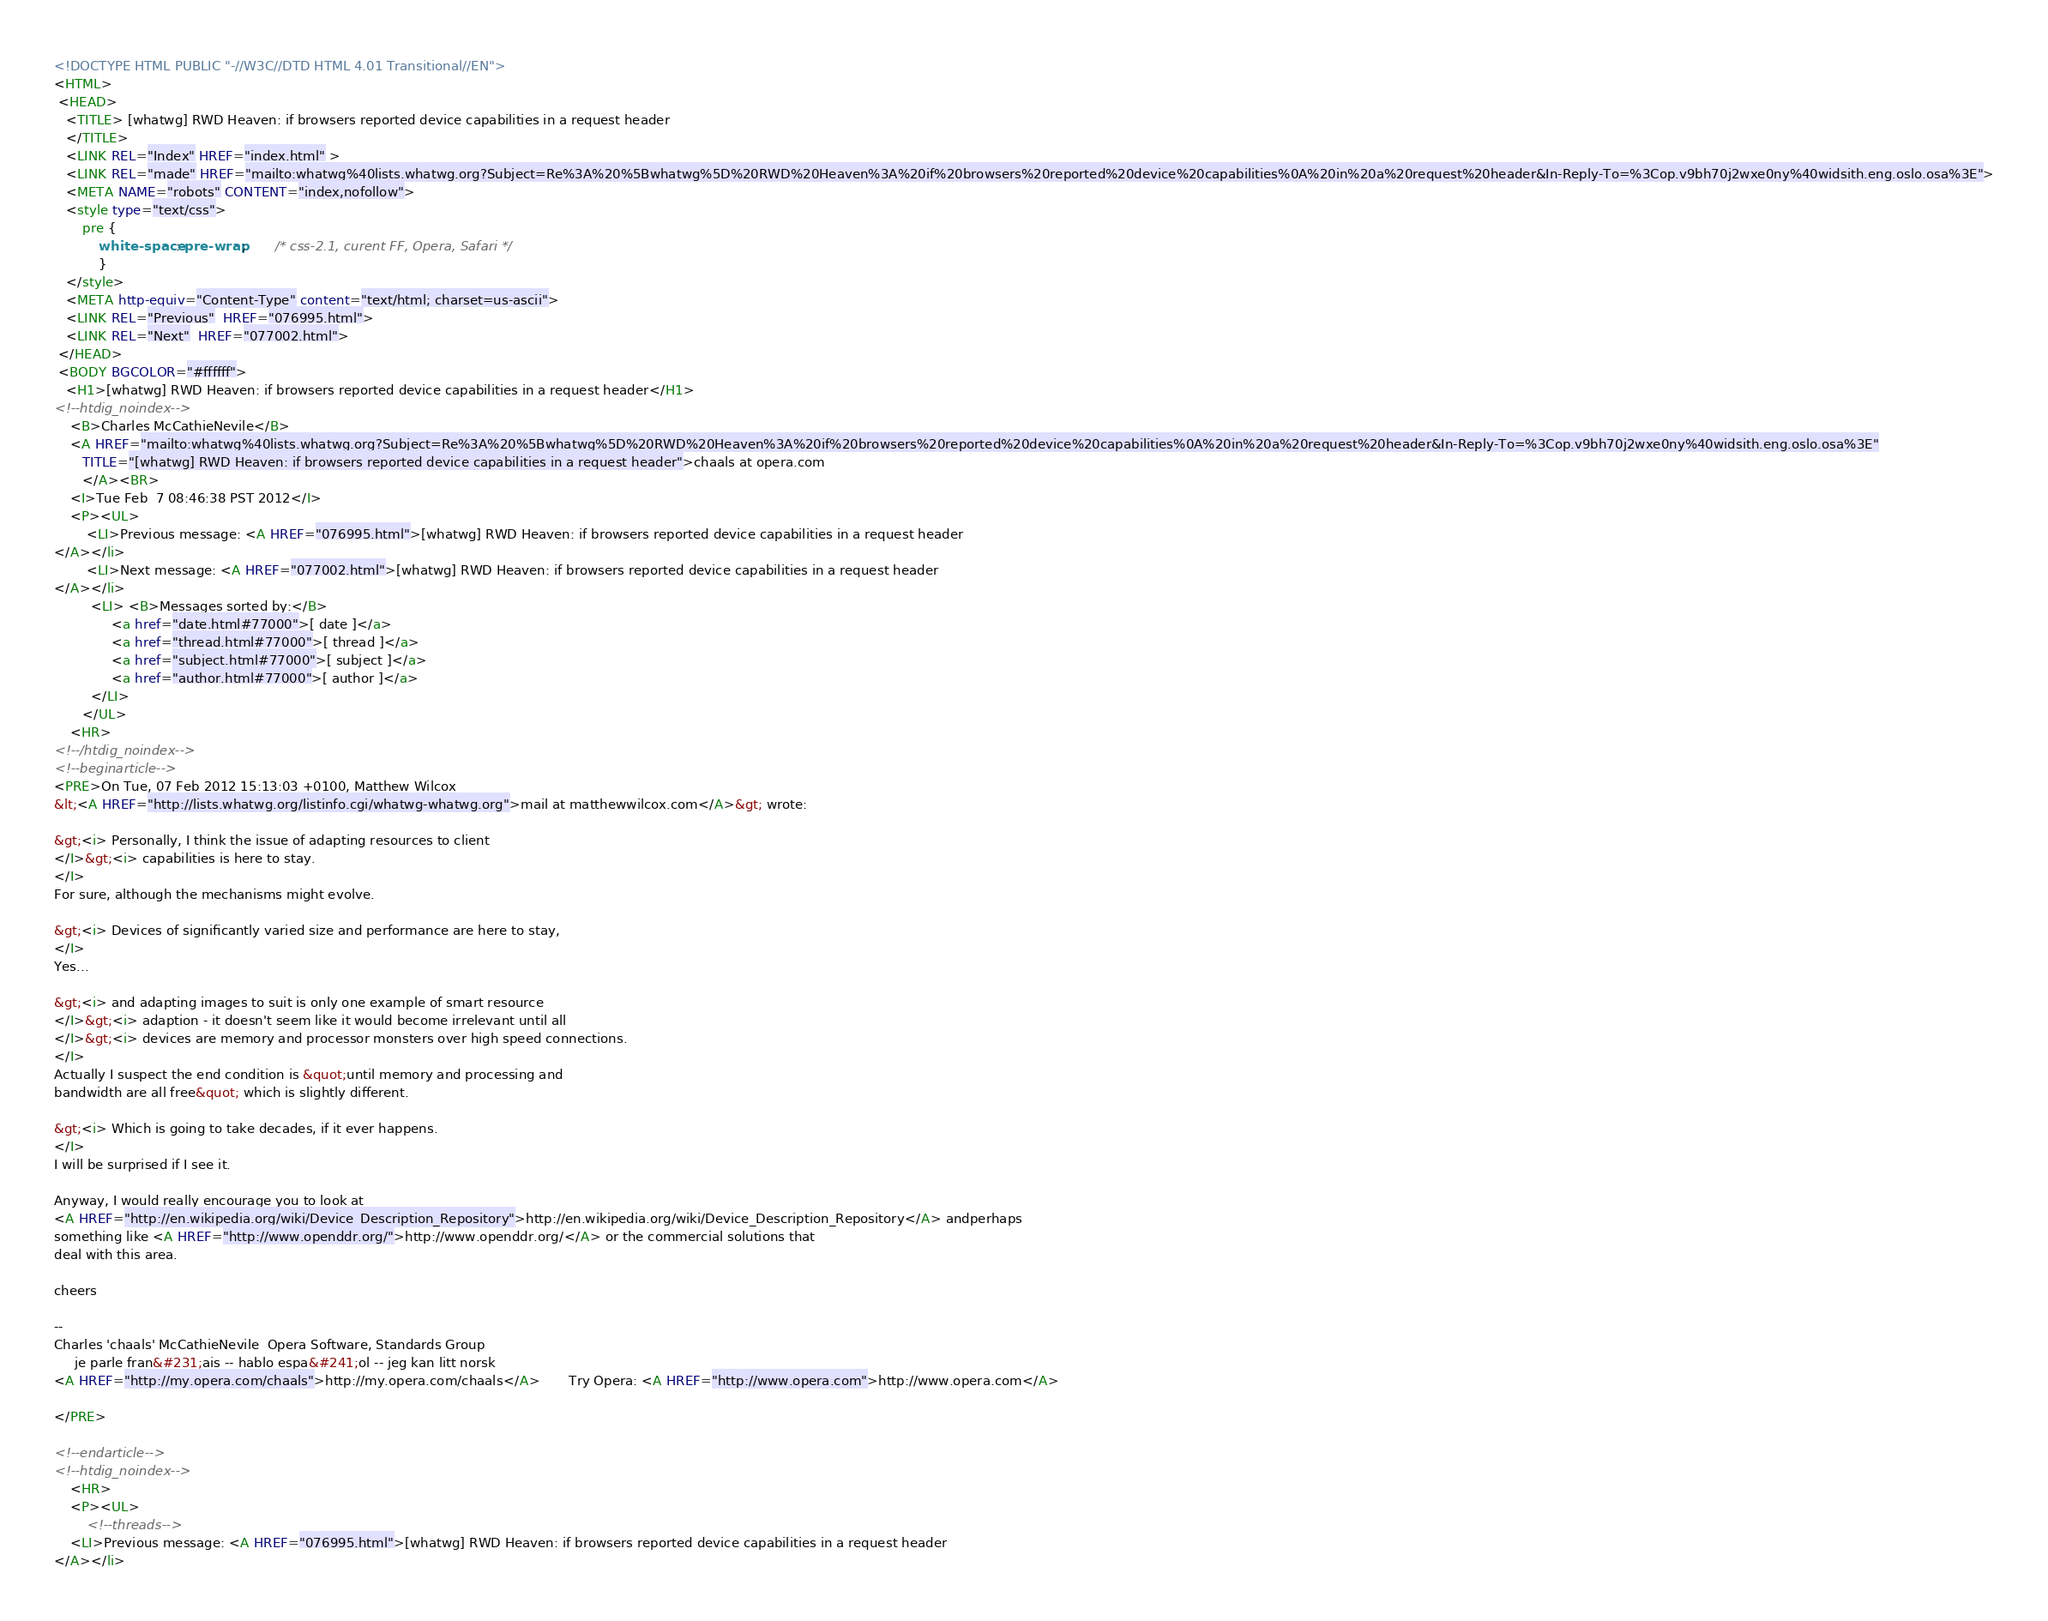<code> <loc_0><loc_0><loc_500><loc_500><_HTML_><!DOCTYPE HTML PUBLIC "-//W3C//DTD HTML 4.01 Transitional//EN">
<HTML>
 <HEAD>
   <TITLE> [whatwg] RWD Heaven: if browsers reported device capabilities in a request header
   </TITLE>
   <LINK REL="Index" HREF="index.html" >
   <LINK REL="made" HREF="mailto:whatwg%40lists.whatwg.org?Subject=Re%3A%20%5Bwhatwg%5D%20RWD%20Heaven%3A%20if%20browsers%20reported%20device%20capabilities%0A%20in%20a%20request%20header&In-Reply-To=%3Cop.v9bh70j2wxe0ny%40widsith.eng.oslo.osa%3E">
   <META NAME="robots" CONTENT="index,nofollow">
   <style type="text/css">
       pre {
           white-space: pre-wrap;       /* css-2.1, curent FF, Opera, Safari */
           }
   </style>
   <META http-equiv="Content-Type" content="text/html; charset=us-ascii">
   <LINK REL="Previous"  HREF="076995.html">
   <LINK REL="Next"  HREF="077002.html">
 </HEAD>
 <BODY BGCOLOR="#ffffff">
   <H1>[whatwg] RWD Heaven: if browsers reported device capabilities in a request header</H1>
<!--htdig_noindex-->
    <B>Charles McCathieNevile</B> 
    <A HREF="mailto:whatwg%40lists.whatwg.org?Subject=Re%3A%20%5Bwhatwg%5D%20RWD%20Heaven%3A%20if%20browsers%20reported%20device%20capabilities%0A%20in%20a%20request%20header&In-Reply-To=%3Cop.v9bh70j2wxe0ny%40widsith.eng.oslo.osa%3E"
       TITLE="[whatwg] RWD Heaven: if browsers reported device capabilities in a request header">chaals at opera.com
       </A><BR>
    <I>Tue Feb  7 08:46:38 PST 2012</I>
    <P><UL>
        <LI>Previous message: <A HREF="076995.html">[whatwg] RWD Heaven: if browsers reported device capabilities in a request header
</A></li>
        <LI>Next message: <A HREF="077002.html">[whatwg] RWD Heaven: if browsers reported device capabilities in a request header
</A></li>
         <LI> <B>Messages sorted by:</B> 
              <a href="date.html#77000">[ date ]</a>
              <a href="thread.html#77000">[ thread ]</a>
              <a href="subject.html#77000">[ subject ]</a>
              <a href="author.html#77000">[ author ]</a>
         </LI>
       </UL>
    <HR>  
<!--/htdig_noindex-->
<!--beginarticle-->
<PRE>On Tue, 07 Feb 2012 15:13:03 +0100, Matthew Wilcox  
&lt;<A HREF="http://lists.whatwg.org/listinfo.cgi/whatwg-whatwg.org">mail at matthewwilcox.com</A>&gt; wrote:

&gt;<i> Personally, I think the issue of adapting resources to client
</I>&gt;<i> capabilities is here to stay.
</I>
For sure, although the mechanisms might evolve.

&gt;<i> Devices of significantly varied size and performance are here to stay,
</I>
Yes...

&gt;<i> and adapting images to suit is only one example of smart resource
</I>&gt;<i> adaption - it doesn't seem like it would become irrelevant until all
</I>&gt;<i> devices are memory and processor monsters over high speed connections.
</I>
Actually I suspect the end condition is &quot;until memory and processing and  
bandwidth are all free&quot; which is slightly different.

&gt;<i> Which is going to take decades, if it ever happens.
</I>
I will be surprised if I see it.

Anyway, I would really encourage you to look at  
<A HREF="http://en.wikipedia.org/wiki/Device_Description_Repository">http://en.wikipedia.org/wiki/Device_Description_Repository</A> andperhaps  
something like <A HREF="http://www.openddr.org/">http://www.openddr.org/</A> or the commercial solutions that  
deal with this area.

cheers

-- 
Charles 'chaals' McCathieNevile  Opera Software, Standards Group
     je parle fran&#231;ais -- hablo espa&#241;ol -- jeg kan litt norsk
<A HREF="http://my.opera.com/chaals">http://my.opera.com/chaals</A>       Try Opera: <A HREF="http://www.opera.com">http://www.opera.com</A>

</PRE>

<!--endarticle-->
<!--htdig_noindex-->
    <HR>
    <P><UL>
        <!--threads-->
	<LI>Previous message: <A HREF="076995.html">[whatwg] RWD Heaven: if browsers reported device capabilities in a request header
</A></li></code> 